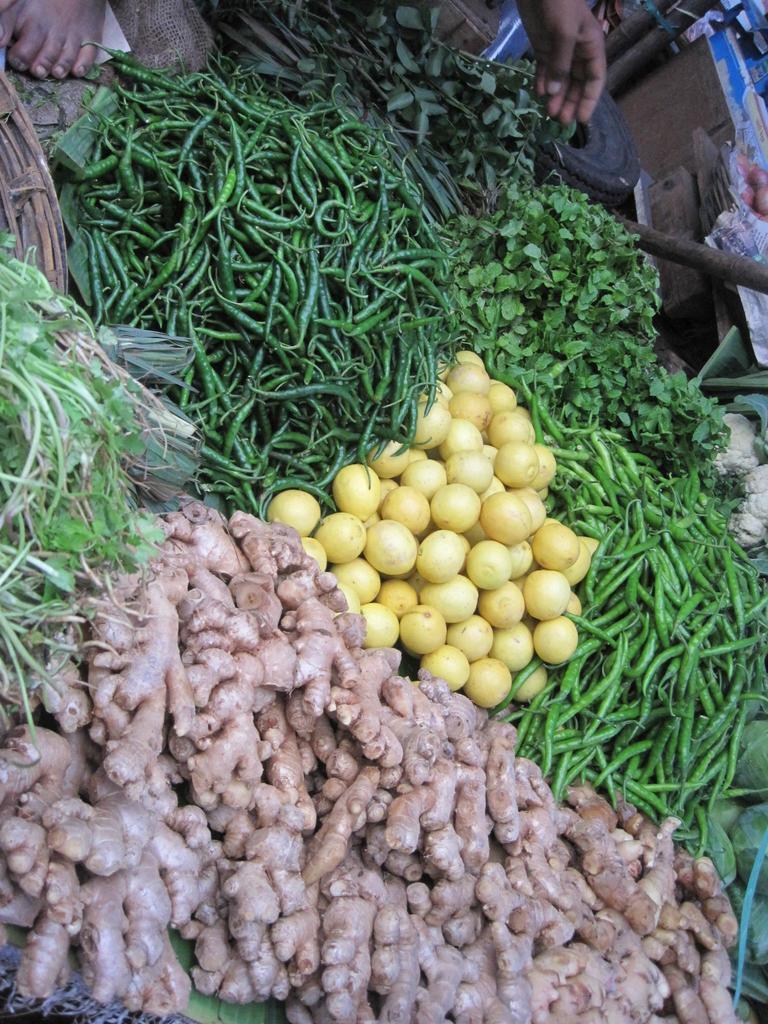How would you summarize this image in a sentence or two? In this image we can see vegetables, leafy vegetables, tire, wooden objects and other objects. At the top of the image there is a person's hand, a person's leg and other objects. 